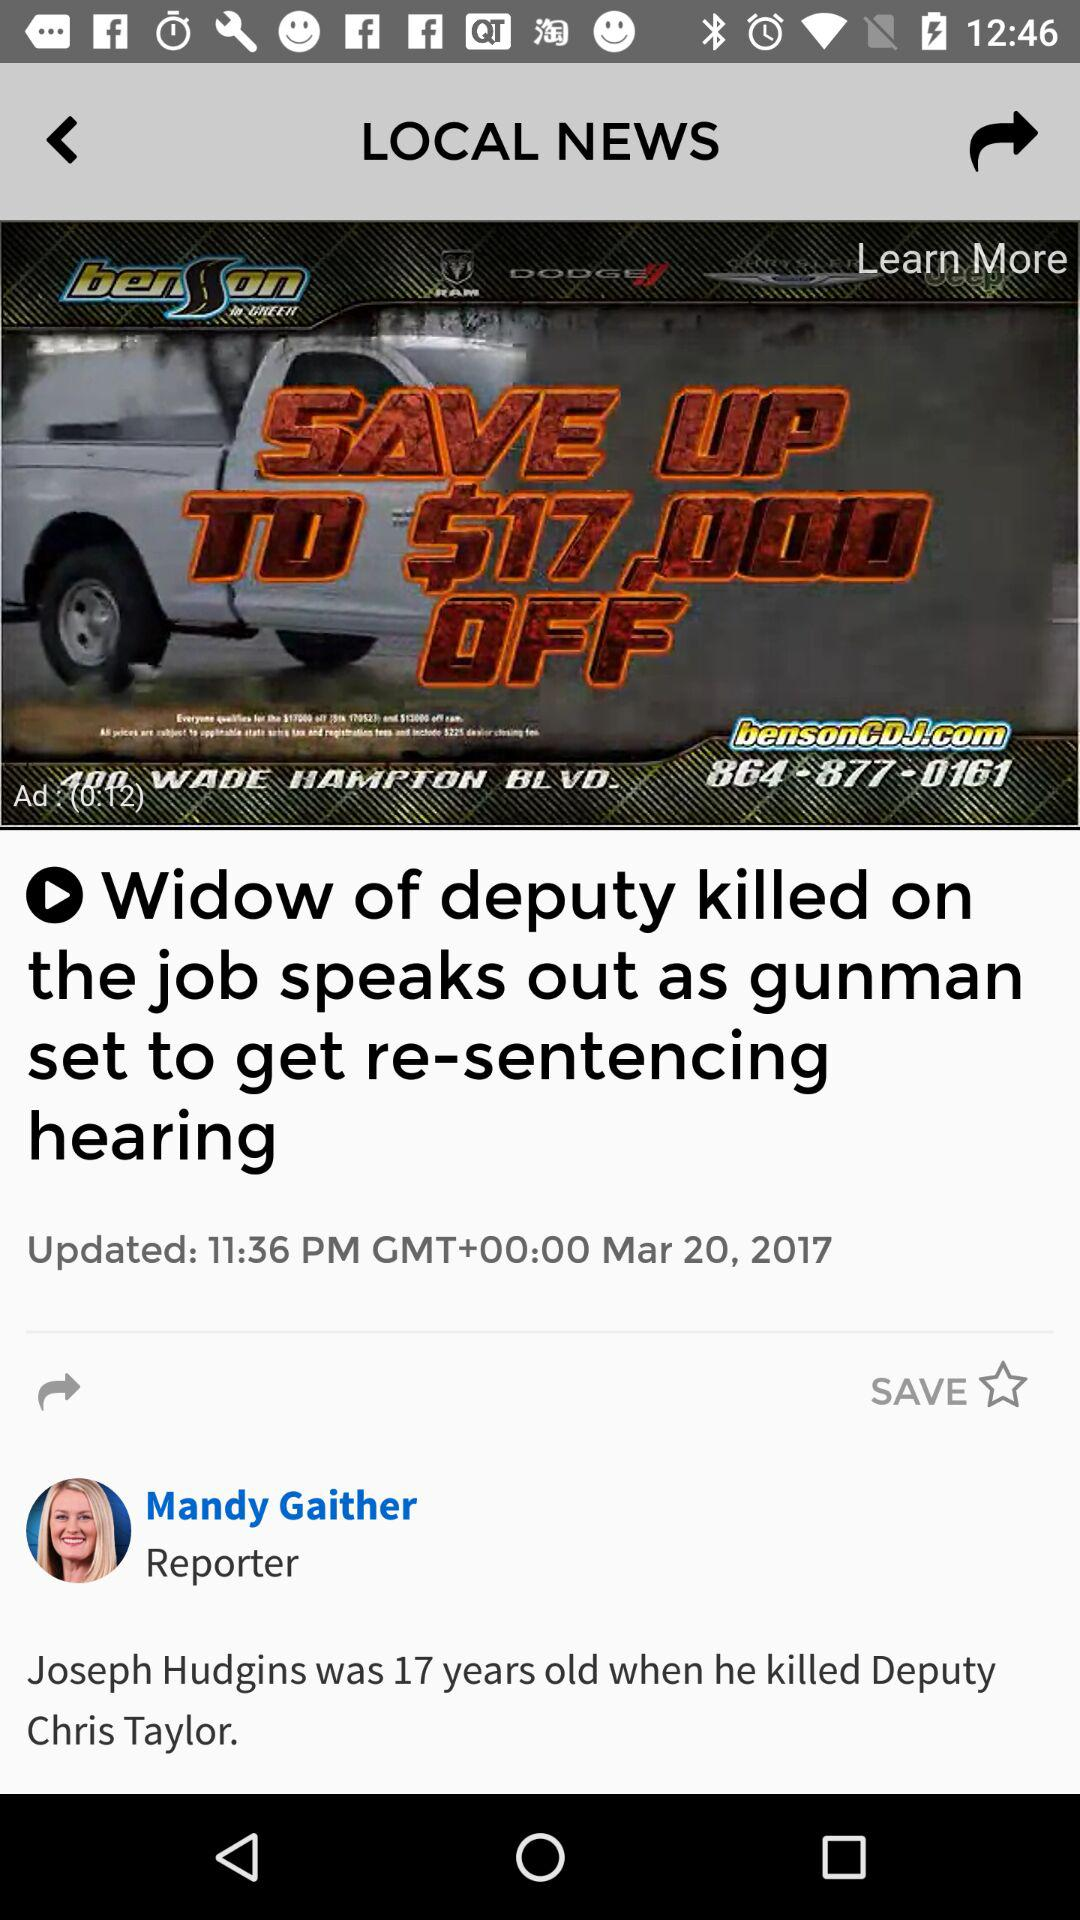At what time was the article updated? The article was updated at 11:36 PM GMT+00:00. 